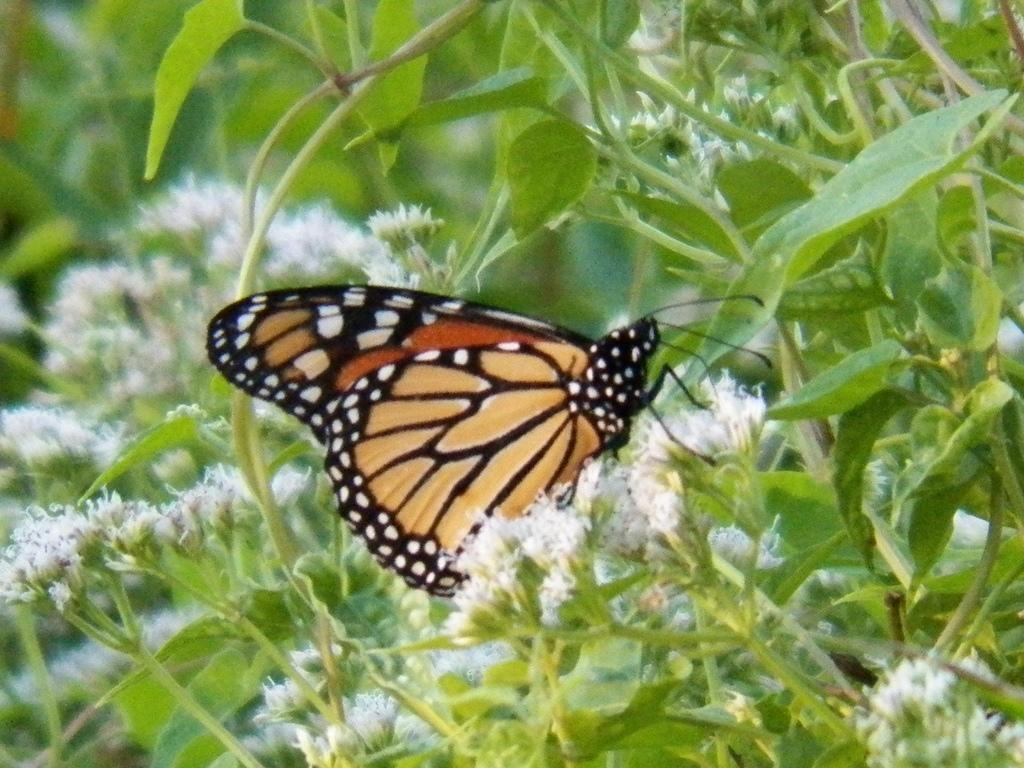What is the main subject of the image? There is a butterfly in the image. Where is the butterfly located in the image? The butterfly is sitting on flowers. What color are the flowers the butterfly is sitting on? The flowers are white. What other types of vegetation can be seen in the image? There are plants and trees in the image. What type of army is visible in the image? There is no army present in the image; it features a butterfly sitting on white flowers. What kind of system is being used to transport the crate in the image? There is no crate present in the image, so it is not possible to determine what kind of system might be used for transportation. 